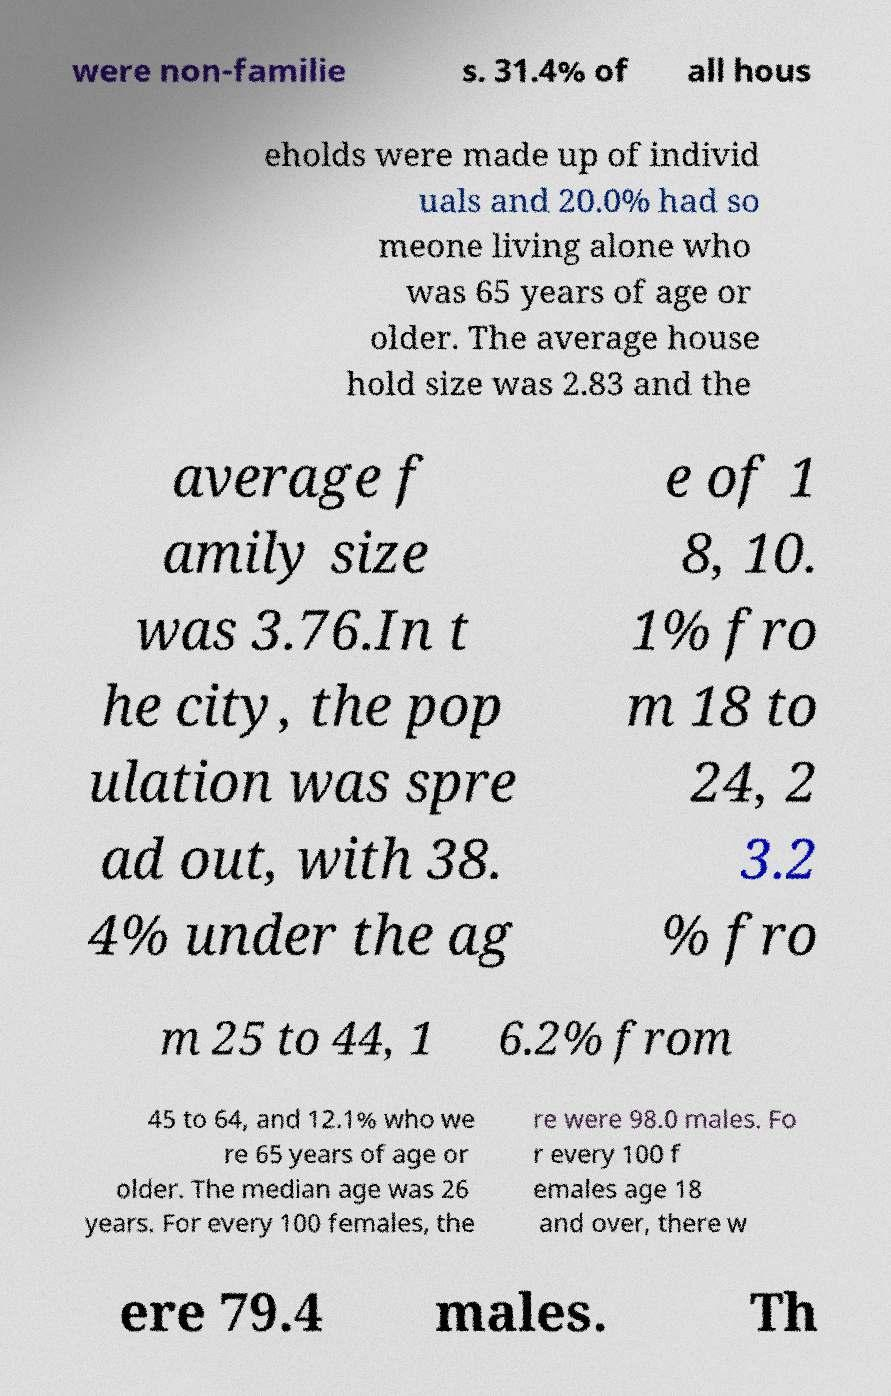Please identify and transcribe the text found in this image. were non-familie s. 31.4% of all hous eholds were made up of individ uals and 20.0% had so meone living alone who was 65 years of age or older. The average house hold size was 2.83 and the average f amily size was 3.76.In t he city, the pop ulation was spre ad out, with 38. 4% under the ag e of 1 8, 10. 1% fro m 18 to 24, 2 3.2 % fro m 25 to 44, 1 6.2% from 45 to 64, and 12.1% who we re 65 years of age or older. The median age was 26 years. For every 100 females, the re were 98.0 males. Fo r every 100 f emales age 18 and over, there w ere 79.4 males. Th 